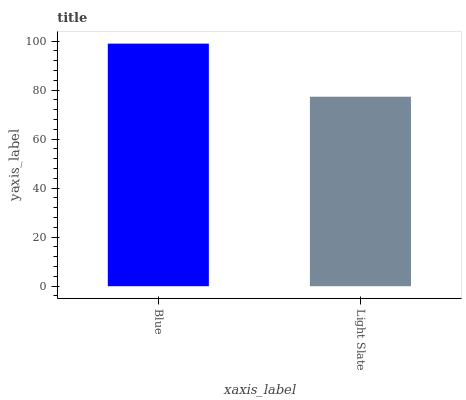Is Light Slate the minimum?
Answer yes or no. Yes. Is Blue the maximum?
Answer yes or no. Yes. Is Light Slate the maximum?
Answer yes or no. No. Is Blue greater than Light Slate?
Answer yes or no. Yes. Is Light Slate less than Blue?
Answer yes or no. Yes. Is Light Slate greater than Blue?
Answer yes or no. No. Is Blue less than Light Slate?
Answer yes or no. No. Is Blue the high median?
Answer yes or no. Yes. Is Light Slate the low median?
Answer yes or no. Yes. Is Light Slate the high median?
Answer yes or no. No. Is Blue the low median?
Answer yes or no. No. 